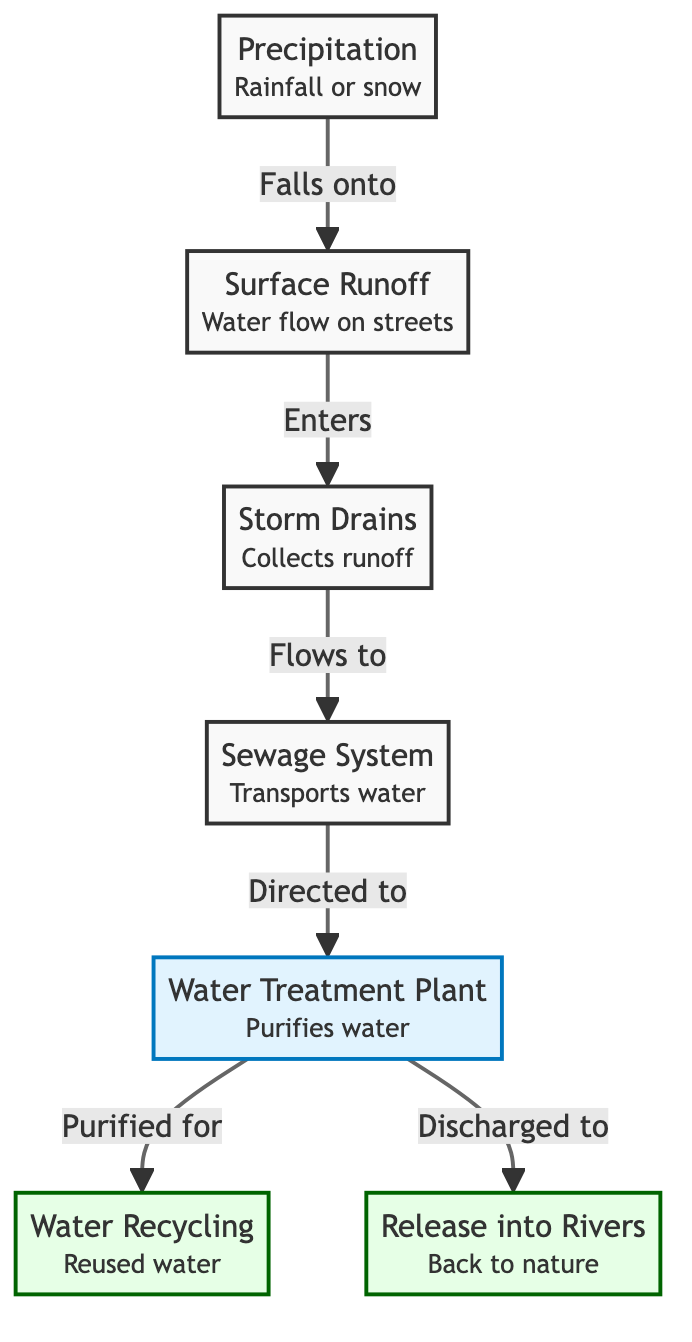What is the first step in the diagram? The diagram begins with precipitation, which represents rainfall or snow. This is the initial input into the water cycle in an urban setting.
Answer: Precipitation How many processes are involved after storm drains? After storm drains, there are two processes illustrated in the diagram: the sewage system and the water treatment plant. These steps are crucial for handling and purifying water.
Answer: 2 What does the sewage system direct water to? The sewage system directs water to the treatment plant, which is a key step for water purification following wastewater collection.
Answer: Treatment Plant What is the outcome of the water treatment plant depicted in the diagram? The water treatment plant has two outputs: one path leads to water recycling (reuse), and the other to the release into rivers, indicating the various ways purified water can be utilized or discharged.
Answer: Water Recycling and Release How does runoff enter the storm drains? Runoff enters the storm drains as it flows from surfaces where water builds up, such as streets and pavements, demonstrating the movement of water from urban areas during rainfall.
Answer: Flows to What happens to water after it is treated at the treatment plant? After treatment, the diagram shows that water is either recycled for reuse or released back into rivers, indicating the dual outcomes of the purification process.
Answer: Reused or Released What role does precipitation have in the water cycle? Precipitation acts as the initial source of water that begins the cycle, signifying its importance in reintroducing water into the urban ecosystem.
Answer: Initial Source What is collected by the storm drains? The storm drains collect surface runoff, which is critical in managing excess water from rain or melting snow in urban environments.
Answer: Runoff How is the water flow represented in the diagram? The water flow in the diagram is represented by directed arrows connecting nodes, showing the sequence from precipitation to its various outcomes after treatment.
Answer: Directed Arrows 